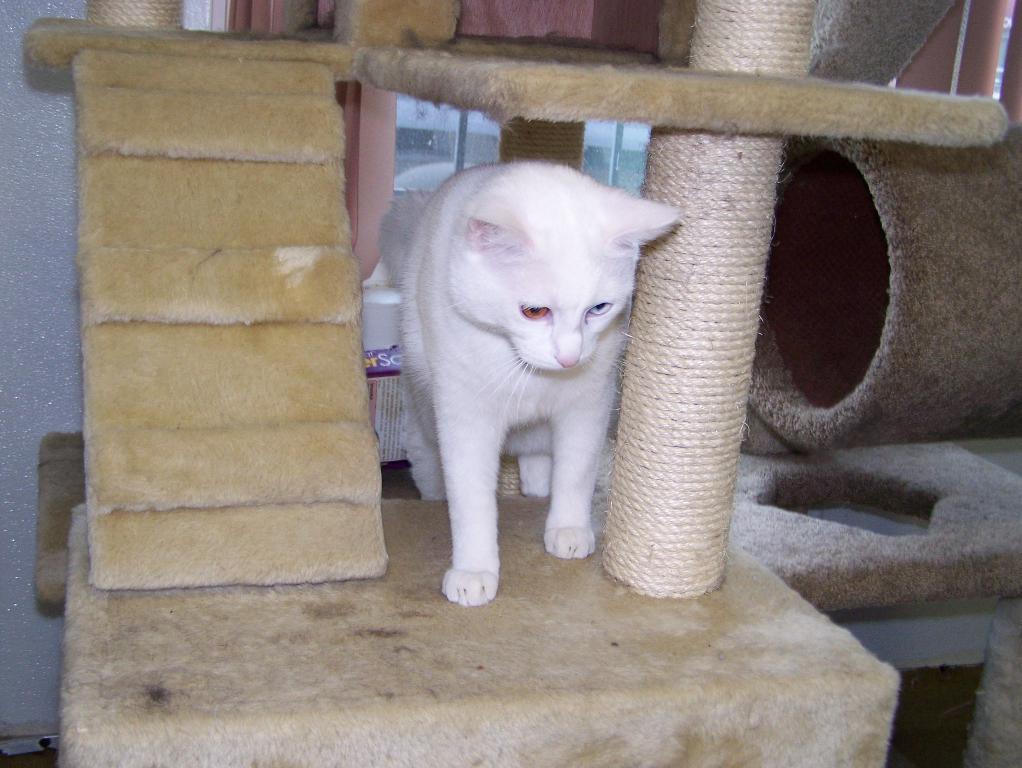Can you describe this image briefly? In this image there is a cat on the cat house. On the right side of the image there are some objects. In the background of the image there is a glass window. 